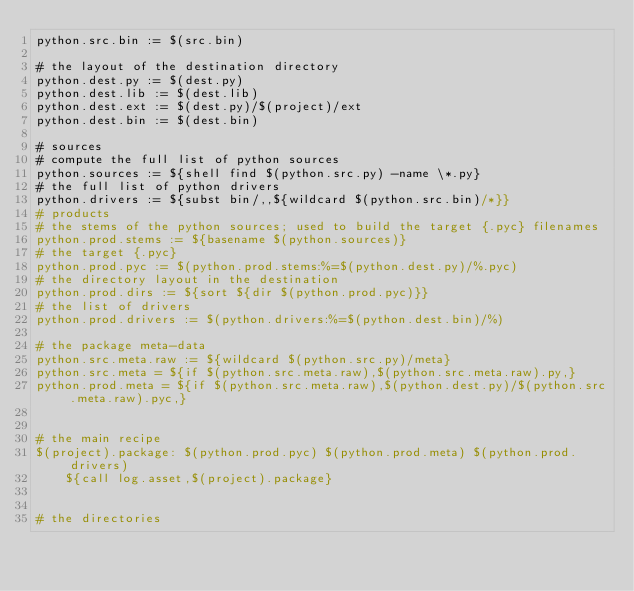<code> <loc_0><loc_0><loc_500><loc_500><_ObjectiveC_>python.src.bin := $(src.bin)

# the layout of the destination directory
python.dest.py := $(dest.py)
python.dest.lib := $(dest.lib)
python.dest.ext := $(dest.py)/$(project)/ext
python.dest.bin := $(dest.bin)

# sources
# compute the full list of python sources
python.sources := ${shell find $(python.src.py) -name \*.py}
# the full list of python drivers
python.drivers := ${subst bin/,,${wildcard $(python.src.bin)/*}}
# products
# the stems of the python sources; used to build the target {.pyc} filenames
python.prod.stems := ${basename $(python.sources)}
# the target {.pyc}
python.prod.pyc := $(python.prod.stems:%=$(python.dest.py)/%.pyc)
# the directory layout in the destination
python.prod.dirs := ${sort ${dir $(python.prod.pyc)}}
# the list of drivers
python.prod.drivers := $(python.drivers:%=$(python.dest.bin)/%)

# the package meta-data
python.src.meta.raw := ${wildcard $(python.src.py)/meta}
python.src.meta = ${if $(python.src.meta.raw),$(python.src.meta.raw).py,}
python.prod.meta = ${if $(python.src.meta.raw),$(python.dest.py)/$(python.src.meta.raw).pyc,}


# the main recipe
$(project).package: $(python.prod.pyc) $(python.prod.meta) $(python.prod.drivers)
	${call log.asset,$(project).package}


# the directories</code> 